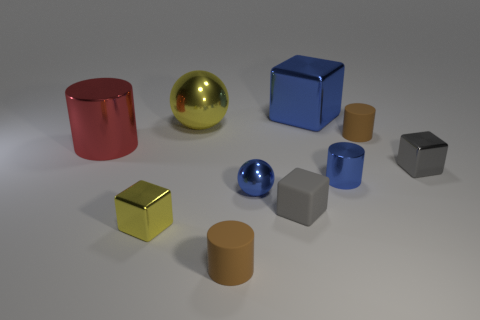How many brown objects have the same shape as the tiny gray shiny thing?
Your answer should be very brief. 0. Is the shape of the tiny shiny thing left of the blue metallic sphere the same as the brown object that is on the right side of the small gray matte thing?
Your answer should be very brief. No. What number of objects are large red shiny things or metallic objects that are to the right of the blue metal block?
Give a very brief answer. 3. What shape is the tiny metal object that is the same color as the big ball?
Give a very brief answer. Cube. How many cylinders have the same size as the yellow metal cube?
Offer a very short reply. 3. How many blue objects are metallic spheres or small metal objects?
Offer a terse response. 2. What shape is the yellow metal object that is behind the small metallic cube on the left side of the blue metal ball?
Offer a terse response. Sphere. What shape is the blue shiny thing that is the same size as the blue cylinder?
Offer a terse response. Sphere. Is there a big cube that has the same color as the tiny shiny sphere?
Provide a succinct answer. Yes. Is the number of gray blocks that are on the left side of the large red thing the same as the number of yellow cubes that are left of the big block?
Make the answer very short. No. 